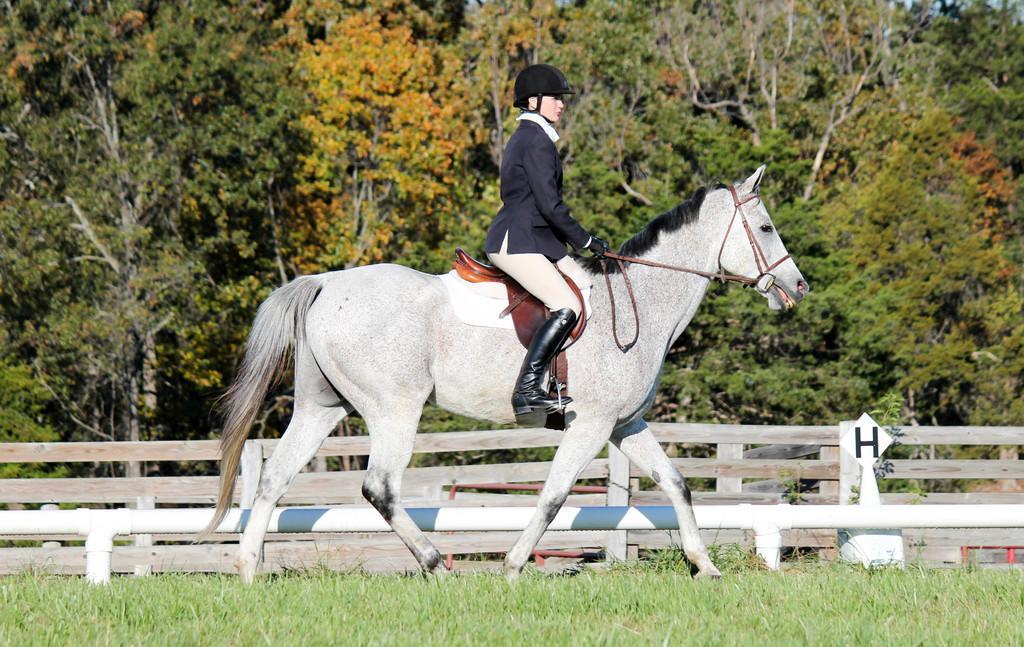How would you summarize this image in a sentence or two? a woman is sitting on the horse and riding in the ground,there are many trees present near the woman. 